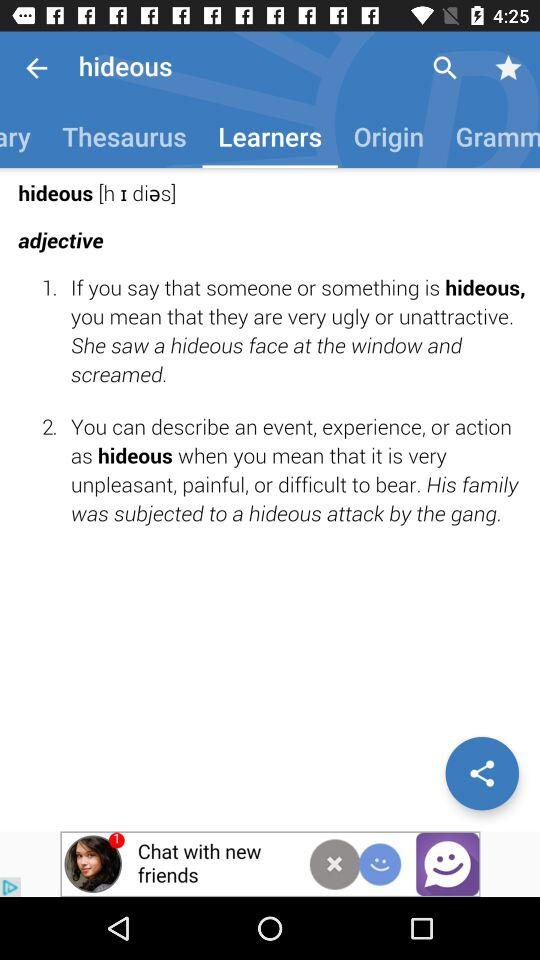How many sentences are there in the definition of hideous?
Answer the question using a single word or phrase. 2 